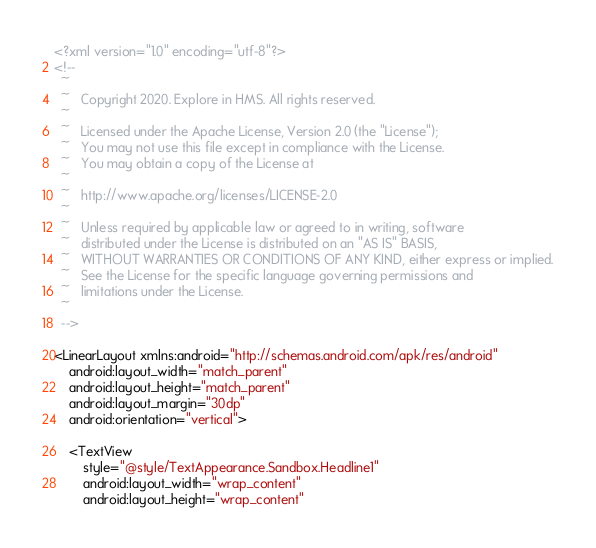Convert code to text. <code><loc_0><loc_0><loc_500><loc_500><_XML_><?xml version="1.0" encoding="utf-8"?>
<!--
  ~
  ~   Copyright 2020. Explore in HMS. All rights reserved.
  ~
  ~   Licensed under the Apache License, Version 2.0 (the "License");
  ~   You may not use this file except in compliance with the License.
  ~   You may obtain a copy of the License at
  ~
  ~   http://www.apache.org/licenses/LICENSE-2.0
  ~
  ~   Unless required by applicable law or agreed to in writing, software
  ~   distributed under the License is distributed on an "AS IS" BASIS,
  ~   WITHOUT WARRANTIES OR CONDITIONS OF ANY KIND, either express or implied.
  ~   See the License for the specific language governing permissions and
  ~   limitations under the License.
  ~
  -->

<LinearLayout xmlns:android="http://schemas.android.com/apk/res/android"
    android:layout_width="match_parent"
    android:layout_height="match_parent"
    android:layout_margin="30dp"
    android:orientation="vertical">

    <TextView
        style="@style/TextAppearance.Sandbox.Headline1"
        android:layout_width="wrap_content"
        android:layout_height="wrap_content"</code> 